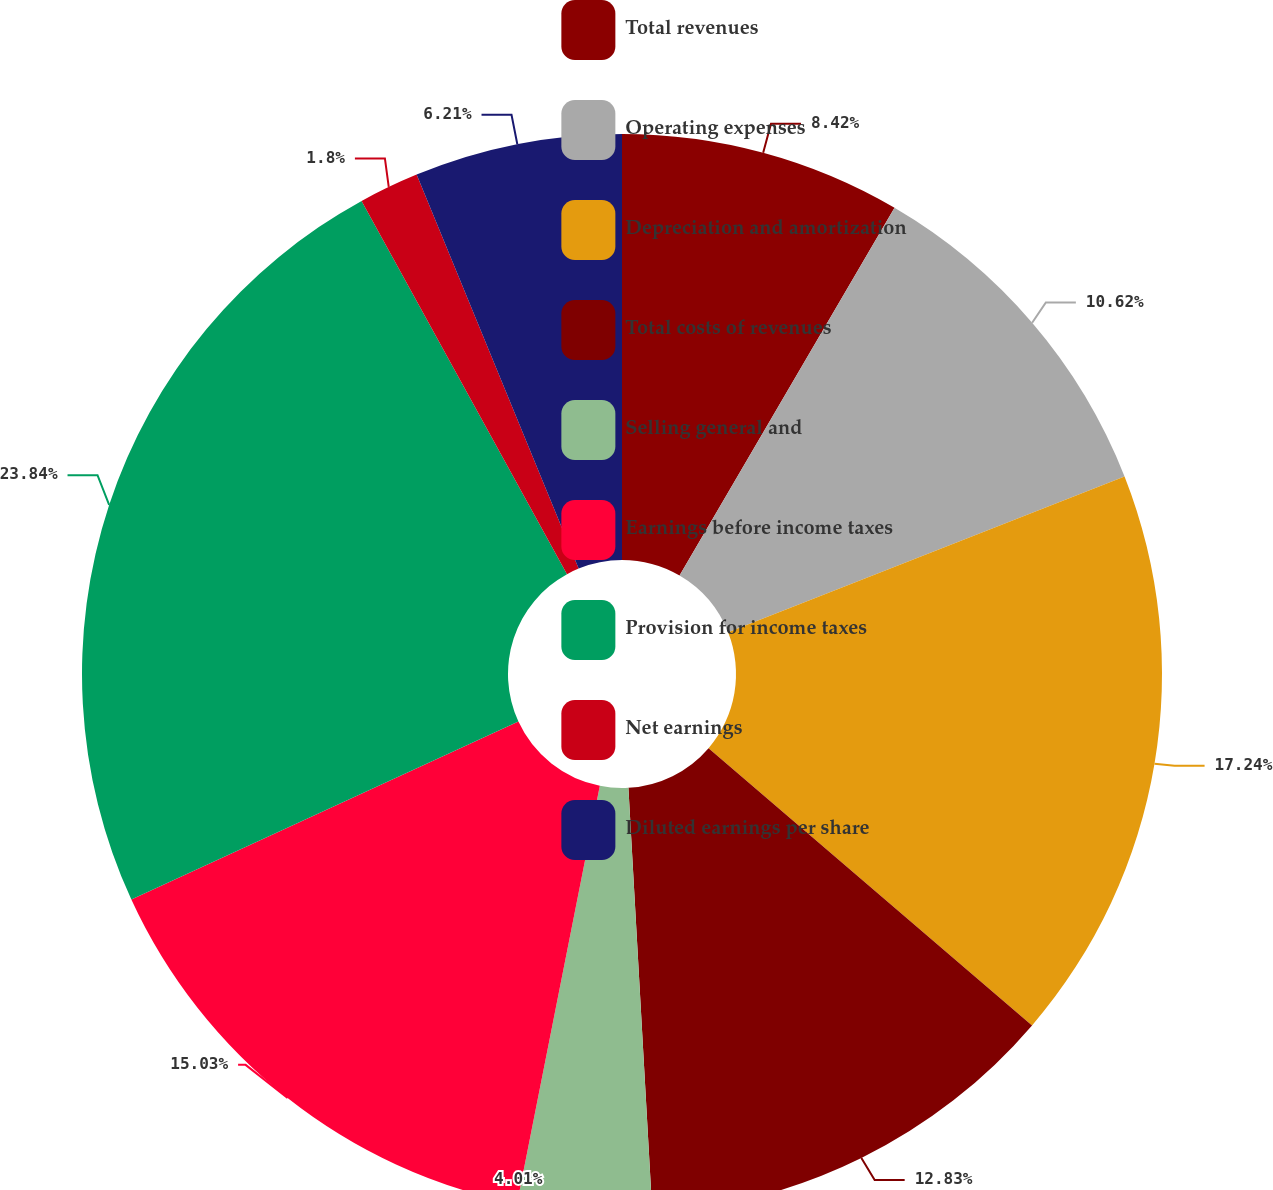<chart> <loc_0><loc_0><loc_500><loc_500><pie_chart><fcel>Total revenues<fcel>Operating expenses<fcel>Depreciation and amortization<fcel>Total costs of revenues<fcel>Selling general and<fcel>Earnings before income taxes<fcel>Provision for income taxes<fcel>Net earnings<fcel>Diluted earnings per share<nl><fcel>8.42%<fcel>10.62%<fcel>17.24%<fcel>12.83%<fcel>4.01%<fcel>15.03%<fcel>23.85%<fcel>1.8%<fcel>6.21%<nl></chart> 